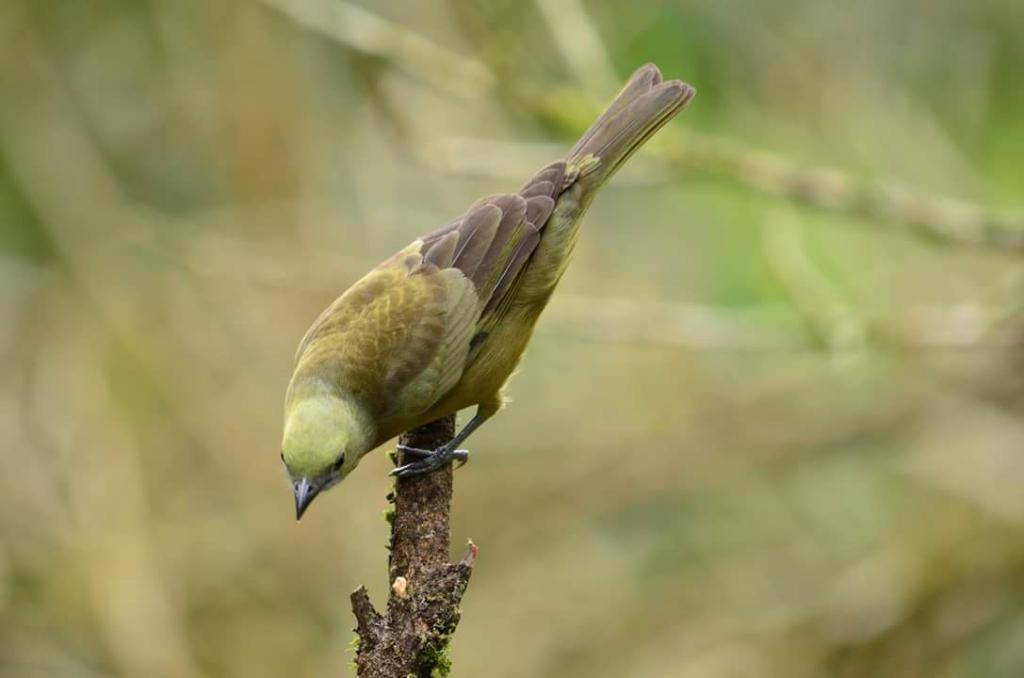What type of animal can be seen in the image? There is a bird in the image. Where is the bird located in the image? The bird is on a stem. What type of mass is the bird holding in its beak during the family gathering in the afternoon? There is no mass, family gathering, or afternoon mentioned in the image. The image only shows a bird on a stem. 